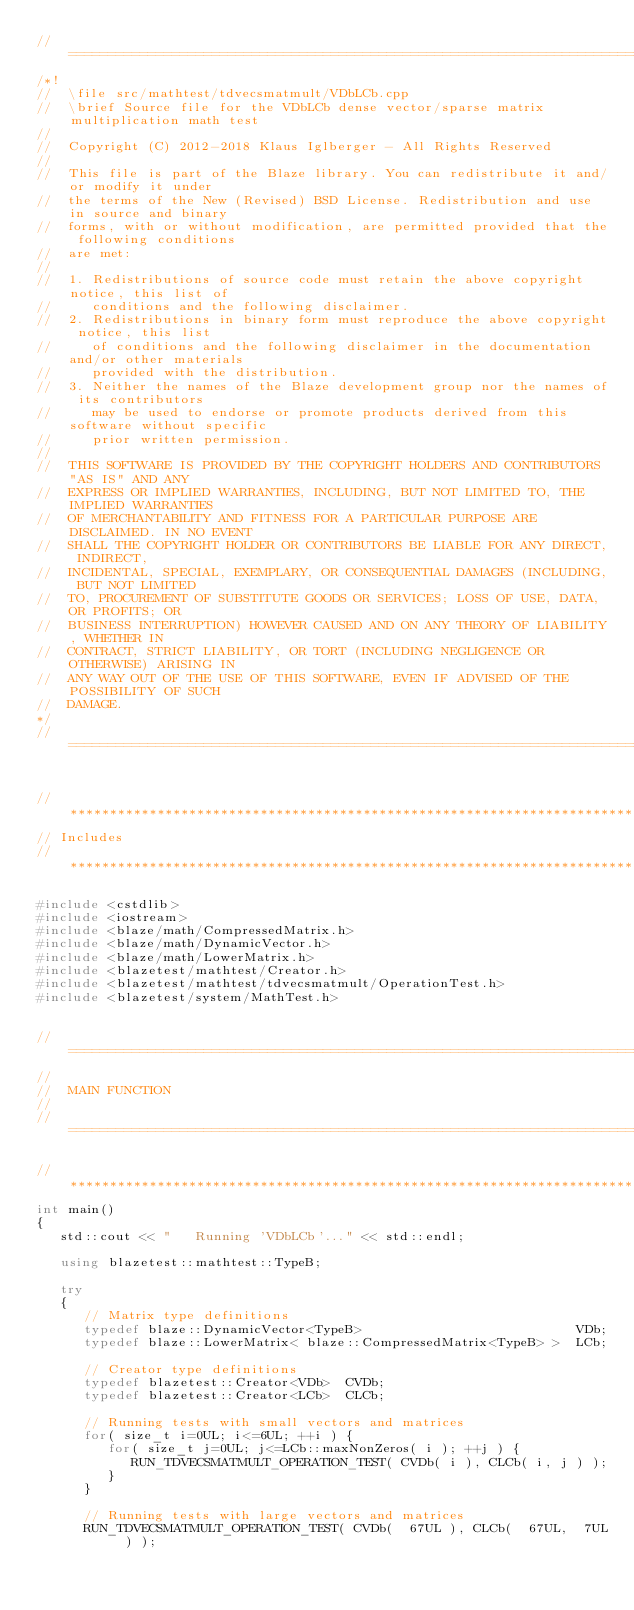Convert code to text. <code><loc_0><loc_0><loc_500><loc_500><_C++_>//=================================================================================================
/*!
//  \file src/mathtest/tdvecsmatmult/VDbLCb.cpp
//  \brief Source file for the VDbLCb dense vector/sparse matrix multiplication math test
//
//  Copyright (C) 2012-2018 Klaus Iglberger - All Rights Reserved
//
//  This file is part of the Blaze library. You can redistribute it and/or modify it under
//  the terms of the New (Revised) BSD License. Redistribution and use in source and binary
//  forms, with or without modification, are permitted provided that the following conditions
//  are met:
//
//  1. Redistributions of source code must retain the above copyright notice, this list of
//     conditions and the following disclaimer.
//  2. Redistributions in binary form must reproduce the above copyright notice, this list
//     of conditions and the following disclaimer in the documentation and/or other materials
//     provided with the distribution.
//  3. Neither the names of the Blaze development group nor the names of its contributors
//     may be used to endorse or promote products derived from this software without specific
//     prior written permission.
//
//  THIS SOFTWARE IS PROVIDED BY THE COPYRIGHT HOLDERS AND CONTRIBUTORS "AS IS" AND ANY
//  EXPRESS OR IMPLIED WARRANTIES, INCLUDING, BUT NOT LIMITED TO, THE IMPLIED WARRANTIES
//  OF MERCHANTABILITY AND FITNESS FOR A PARTICULAR PURPOSE ARE DISCLAIMED. IN NO EVENT
//  SHALL THE COPYRIGHT HOLDER OR CONTRIBUTORS BE LIABLE FOR ANY DIRECT, INDIRECT,
//  INCIDENTAL, SPECIAL, EXEMPLARY, OR CONSEQUENTIAL DAMAGES (INCLUDING, BUT NOT LIMITED
//  TO, PROCUREMENT OF SUBSTITUTE GOODS OR SERVICES; LOSS OF USE, DATA, OR PROFITS; OR
//  BUSINESS INTERRUPTION) HOWEVER CAUSED AND ON ANY THEORY OF LIABILITY, WHETHER IN
//  CONTRACT, STRICT LIABILITY, OR TORT (INCLUDING NEGLIGENCE OR OTHERWISE) ARISING IN
//  ANY WAY OUT OF THE USE OF THIS SOFTWARE, EVEN IF ADVISED OF THE POSSIBILITY OF SUCH
//  DAMAGE.
*/
//=================================================================================================


//*************************************************************************************************
// Includes
//*************************************************************************************************

#include <cstdlib>
#include <iostream>
#include <blaze/math/CompressedMatrix.h>
#include <blaze/math/DynamicVector.h>
#include <blaze/math/LowerMatrix.h>
#include <blazetest/mathtest/Creator.h>
#include <blazetest/mathtest/tdvecsmatmult/OperationTest.h>
#include <blazetest/system/MathTest.h>


//=================================================================================================
//
//  MAIN FUNCTION
//
//=================================================================================================

//*************************************************************************************************
int main()
{
   std::cout << "   Running 'VDbLCb'..." << std::endl;

   using blazetest::mathtest::TypeB;

   try
   {
      // Matrix type definitions
      typedef blaze::DynamicVector<TypeB>                           VDb;
      typedef blaze::LowerMatrix< blaze::CompressedMatrix<TypeB> >  LCb;

      // Creator type definitions
      typedef blazetest::Creator<VDb>  CVDb;
      typedef blazetest::Creator<LCb>  CLCb;

      // Running tests with small vectors and matrices
      for( size_t i=0UL; i<=6UL; ++i ) {
         for( size_t j=0UL; j<=LCb::maxNonZeros( i ); ++j ) {
            RUN_TDVECSMATMULT_OPERATION_TEST( CVDb( i ), CLCb( i, j ) );
         }
      }

      // Running tests with large vectors and matrices
      RUN_TDVECSMATMULT_OPERATION_TEST( CVDb(  67UL ), CLCb(  67UL,  7UL ) );</code> 